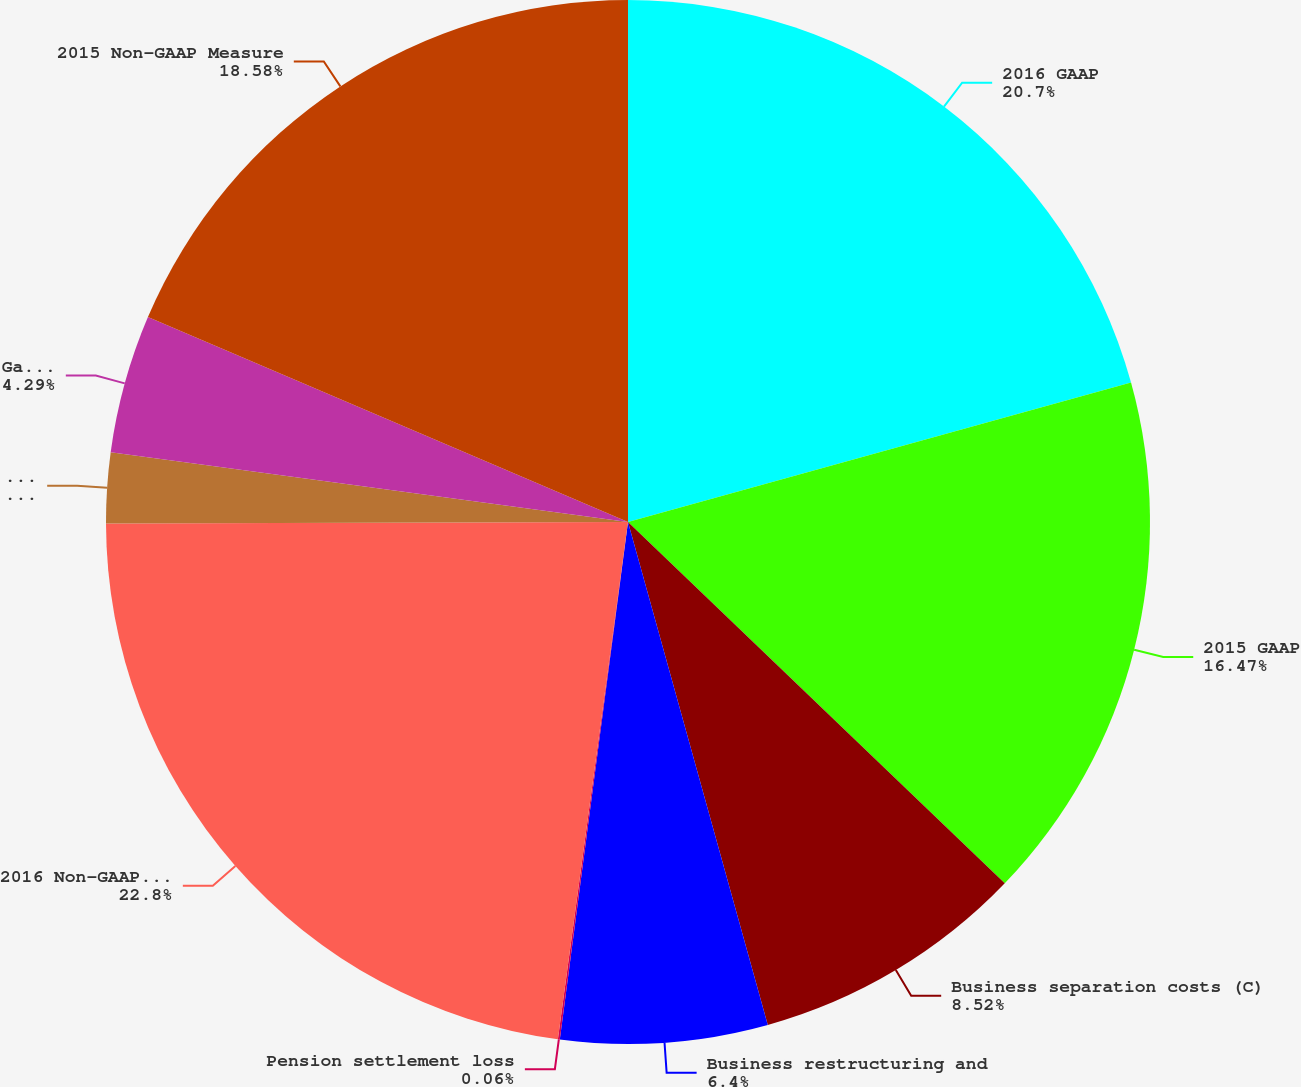Convert chart. <chart><loc_0><loc_0><loc_500><loc_500><pie_chart><fcel>2016 GAAP<fcel>2015 GAAP<fcel>Business separation costs (C)<fcel>Business restructuring and<fcel>Pension settlement loss<fcel>2016 Non-GAAP Measure<fcel>Gain on previously held equity<fcel>Gain on land sales (E)<fcel>2015 Non-GAAP Measure<nl><fcel>20.7%<fcel>16.47%<fcel>8.52%<fcel>6.4%<fcel>0.06%<fcel>22.81%<fcel>2.18%<fcel>4.29%<fcel>18.58%<nl></chart> 